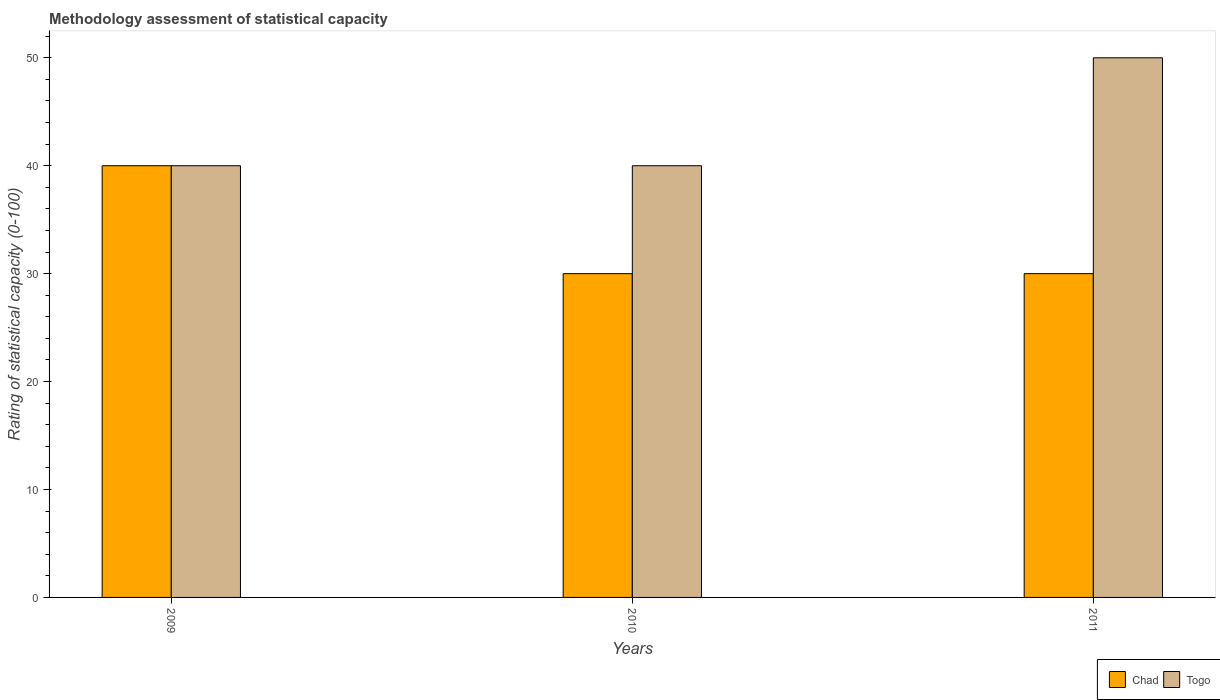How many different coloured bars are there?
Provide a short and direct response. 2. How many bars are there on the 3rd tick from the left?
Provide a short and direct response. 2. How many bars are there on the 1st tick from the right?
Provide a succinct answer. 2. What is the label of the 3rd group of bars from the left?
Ensure brevity in your answer.  2011. What is the rating of statistical capacity in Togo in 2011?
Your answer should be compact. 50. Across all years, what is the maximum rating of statistical capacity in Togo?
Offer a very short reply. 50. Across all years, what is the minimum rating of statistical capacity in Chad?
Your answer should be very brief. 30. What is the total rating of statistical capacity in Chad in the graph?
Offer a very short reply. 100. What is the difference between the rating of statistical capacity in Togo in 2010 and that in 2011?
Keep it short and to the point. -10. What is the difference between the rating of statistical capacity in Togo in 2011 and the rating of statistical capacity in Chad in 2010?
Your response must be concise. 20. What is the average rating of statistical capacity in Togo per year?
Your answer should be very brief. 43.33. In the year 2011, what is the difference between the rating of statistical capacity in Togo and rating of statistical capacity in Chad?
Offer a very short reply. 20. In how many years, is the rating of statistical capacity in Chad greater than 8?
Offer a terse response. 3. What is the ratio of the rating of statistical capacity in Chad in 2009 to that in 2010?
Offer a very short reply. 1.33. Is the rating of statistical capacity in Chad in 2009 less than that in 2011?
Offer a very short reply. No. Is the difference between the rating of statistical capacity in Togo in 2009 and 2010 greater than the difference between the rating of statistical capacity in Chad in 2009 and 2010?
Offer a very short reply. No. What is the difference between the highest and the lowest rating of statistical capacity in Togo?
Offer a terse response. 10. Is the sum of the rating of statistical capacity in Togo in 2009 and 2010 greater than the maximum rating of statistical capacity in Chad across all years?
Give a very brief answer. Yes. What does the 2nd bar from the left in 2010 represents?
Ensure brevity in your answer.  Togo. What does the 1st bar from the right in 2010 represents?
Provide a short and direct response. Togo. Are all the bars in the graph horizontal?
Give a very brief answer. No. Does the graph contain any zero values?
Your answer should be very brief. No. Does the graph contain grids?
Ensure brevity in your answer.  No. Where does the legend appear in the graph?
Provide a succinct answer. Bottom right. How many legend labels are there?
Ensure brevity in your answer.  2. What is the title of the graph?
Your answer should be very brief. Methodology assessment of statistical capacity. Does "Angola" appear as one of the legend labels in the graph?
Provide a succinct answer. No. What is the label or title of the Y-axis?
Keep it short and to the point. Rating of statistical capacity (0-100). What is the Rating of statistical capacity (0-100) of Chad in 2009?
Your answer should be very brief. 40. What is the Rating of statistical capacity (0-100) of Chad in 2010?
Make the answer very short. 30. What is the Rating of statistical capacity (0-100) in Togo in 2010?
Make the answer very short. 40. What is the Rating of statistical capacity (0-100) of Chad in 2011?
Offer a very short reply. 30. What is the Rating of statistical capacity (0-100) of Togo in 2011?
Ensure brevity in your answer.  50. Across all years, what is the maximum Rating of statistical capacity (0-100) in Chad?
Your response must be concise. 40. Across all years, what is the maximum Rating of statistical capacity (0-100) of Togo?
Provide a short and direct response. 50. Across all years, what is the minimum Rating of statistical capacity (0-100) in Togo?
Give a very brief answer. 40. What is the total Rating of statistical capacity (0-100) of Togo in the graph?
Offer a terse response. 130. What is the difference between the Rating of statistical capacity (0-100) of Chad in 2009 and that in 2010?
Make the answer very short. 10. What is the difference between the Rating of statistical capacity (0-100) in Chad in 2009 and that in 2011?
Provide a succinct answer. 10. What is the difference between the Rating of statistical capacity (0-100) of Togo in 2009 and that in 2011?
Offer a terse response. -10. What is the difference between the Rating of statistical capacity (0-100) in Togo in 2010 and that in 2011?
Keep it short and to the point. -10. What is the difference between the Rating of statistical capacity (0-100) of Chad in 2009 and the Rating of statistical capacity (0-100) of Togo in 2010?
Your answer should be compact. 0. What is the average Rating of statistical capacity (0-100) of Chad per year?
Your answer should be compact. 33.33. What is the average Rating of statistical capacity (0-100) of Togo per year?
Offer a very short reply. 43.33. In the year 2009, what is the difference between the Rating of statistical capacity (0-100) in Chad and Rating of statistical capacity (0-100) in Togo?
Give a very brief answer. 0. In the year 2010, what is the difference between the Rating of statistical capacity (0-100) of Chad and Rating of statistical capacity (0-100) of Togo?
Your answer should be very brief. -10. What is the ratio of the Rating of statistical capacity (0-100) in Chad in 2009 to that in 2010?
Provide a succinct answer. 1.33. What is the ratio of the Rating of statistical capacity (0-100) of Togo in 2009 to that in 2010?
Your answer should be very brief. 1. What is the ratio of the Rating of statistical capacity (0-100) in Chad in 2009 to that in 2011?
Offer a terse response. 1.33. What is the ratio of the Rating of statistical capacity (0-100) of Chad in 2010 to that in 2011?
Ensure brevity in your answer.  1. What is the difference between the highest and the lowest Rating of statistical capacity (0-100) of Chad?
Your response must be concise. 10. What is the difference between the highest and the lowest Rating of statistical capacity (0-100) in Togo?
Make the answer very short. 10. 